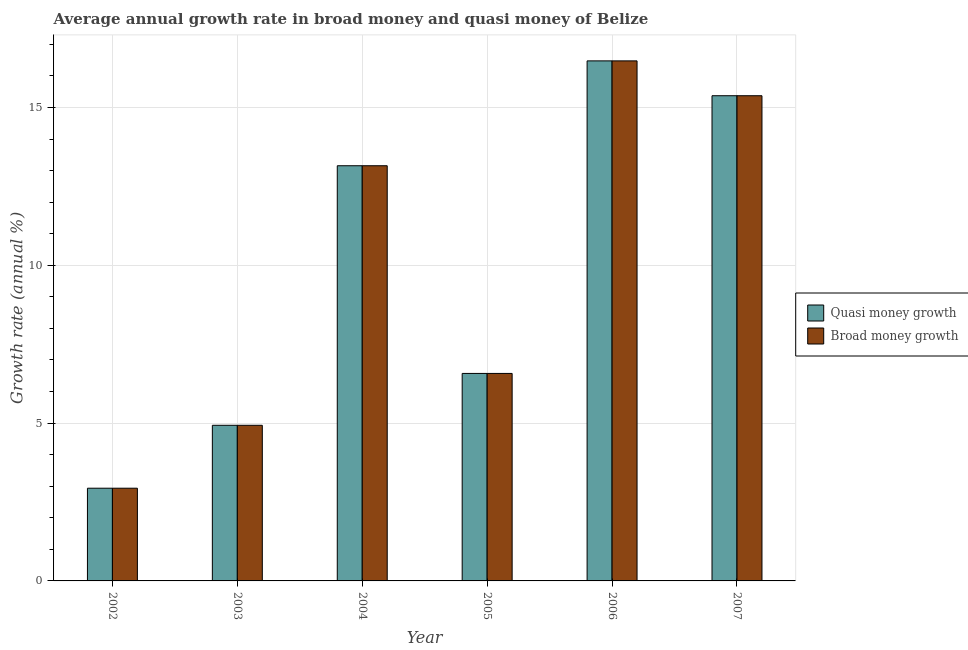How many different coloured bars are there?
Provide a short and direct response. 2. Are the number of bars per tick equal to the number of legend labels?
Ensure brevity in your answer.  Yes. How many bars are there on the 1st tick from the left?
Make the answer very short. 2. How many bars are there on the 1st tick from the right?
Your response must be concise. 2. What is the label of the 4th group of bars from the left?
Provide a short and direct response. 2005. What is the annual growth rate in quasi money in 2007?
Keep it short and to the point. 15.37. Across all years, what is the maximum annual growth rate in broad money?
Your response must be concise. 16.48. Across all years, what is the minimum annual growth rate in quasi money?
Your answer should be very brief. 2.94. In which year was the annual growth rate in quasi money minimum?
Ensure brevity in your answer.  2002. What is the total annual growth rate in quasi money in the graph?
Offer a very short reply. 59.44. What is the difference between the annual growth rate in quasi money in 2002 and that in 2004?
Your response must be concise. -10.22. What is the difference between the annual growth rate in broad money in 2005 and the annual growth rate in quasi money in 2007?
Ensure brevity in your answer.  -8.8. What is the average annual growth rate in quasi money per year?
Make the answer very short. 9.91. In the year 2005, what is the difference between the annual growth rate in quasi money and annual growth rate in broad money?
Offer a very short reply. 0. In how many years, is the annual growth rate in broad money greater than 14 %?
Your response must be concise. 2. What is the ratio of the annual growth rate in broad money in 2005 to that in 2007?
Make the answer very short. 0.43. What is the difference between the highest and the second highest annual growth rate in broad money?
Provide a short and direct response. 1.1. What is the difference between the highest and the lowest annual growth rate in quasi money?
Offer a very short reply. 13.54. In how many years, is the annual growth rate in quasi money greater than the average annual growth rate in quasi money taken over all years?
Keep it short and to the point. 3. What does the 1st bar from the left in 2004 represents?
Keep it short and to the point. Quasi money growth. What does the 2nd bar from the right in 2007 represents?
Make the answer very short. Quasi money growth. Are all the bars in the graph horizontal?
Your response must be concise. No. Are the values on the major ticks of Y-axis written in scientific E-notation?
Your answer should be very brief. No. Does the graph contain grids?
Keep it short and to the point. Yes. Where does the legend appear in the graph?
Provide a succinct answer. Center right. How many legend labels are there?
Offer a terse response. 2. How are the legend labels stacked?
Your answer should be compact. Vertical. What is the title of the graph?
Ensure brevity in your answer.  Average annual growth rate in broad money and quasi money of Belize. Does "Start a business" appear as one of the legend labels in the graph?
Your answer should be very brief. No. What is the label or title of the Y-axis?
Your answer should be compact. Growth rate (annual %). What is the Growth rate (annual %) of Quasi money growth in 2002?
Keep it short and to the point. 2.94. What is the Growth rate (annual %) in Broad money growth in 2002?
Make the answer very short. 2.94. What is the Growth rate (annual %) in Quasi money growth in 2003?
Provide a short and direct response. 4.93. What is the Growth rate (annual %) of Broad money growth in 2003?
Your answer should be compact. 4.93. What is the Growth rate (annual %) of Quasi money growth in 2004?
Your answer should be very brief. 13.15. What is the Growth rate (annual %) in Broad money growth in 2004?
Make the answer very short. 13.15. What is the Growth rate (annual %) of Quasi money growth in 2005?
Your answer should be very brief. 6.57. What is the Growth rate (annual %) of Broad money growth in 2005?
Provide a succinct answer. 6.57. What is the Growth rate (annual %) in Quasi money growth in 2006?
Your response must be concise. 16.48. What is the Growth rate (annual %) in Broad money growth in 2006?
Ensure brevity in your answer.  16.48. What is the Growth rate (annual %) of Quasi money growth in 2007?
Give a very brief answer. 15.37. What is the Growth rate (annual %) of Broad money growth in 2007?
Provide a succinct answer. 15.37. Across all years, what is the maximum Growth rate (annual %) of Quasi money growth?
Ensure brevity in your answer.  16.48. Across all years, what is the maximum Growth rate (annual %) of Broad money growth?
Give a very brief answer. 16.48. Across all years, what is the minimum Growth rate (annual %) in Quasi money growth?
Keep it short and to the point. 2.94. Across all years, what is the minimum Growth rate (annual %) of Broad money growth?
Keep it short and to the point. 2.94. What is the total Growth rate (annual %) of Quasi money growth in the graph?
Your response must be concise. 59.44. What is the total Growth rate (annual %) of Broad money growth in the graph?
Offer a very short reply. 59.44. What is the difference between the Growth rate (annual %) of Quasi money growth in 2002 and that in 2003?
Your answer should be very brief. -1.99. What is the difference between the Growth rate (annual %) in Broad money growth in 2002 and that in 2003?
Your answer should be very brief. -1.99. What is the difference between the Growth rate (annual %) of Quasi money growth in 2002 and that in 2004?
Keep it short and to the point. -10.22. What is the difference between the Growth rate (annual %) in Broad money growth in 2002 and that in 2004?
Your answer should be very brief. -10.22. What is the difference between the Growth rate (annual %) in Quasi money growth in 2002 and that in 2005?
Provide a succinct answer. -3.64. What is the difference between the Growth rate (annual %) of Broad money growth in 2002 and that in 2005?
Your answer should be very brief. -3.64. What is the difference between the Growth rate (annual %) in Quasi money growth in 2002 and that in 2006?
Provide a succinct answer. -13.54. What is the difference between the Growth rate (annual %) in Broad money growth in 2002 and that in 2006?
Your response must be concise. -13.54. What is the difference between the Growth rate (annual %) of Quasi money growth in 2002 and that in 2007?
Provide a succinct answer. -12.43. What is the difference between the Growth rate (annual %) in Broad money growth in 2002 and that in 2007?
Offer a terse response. -12.43. What is the difference between the Growth rate (annual %) of Quasi money growth in 2003 and that in 2004?
Your response must be concise. -8.22. What is the difference between the Growth rate (annual %) in Broad money growth in 2003 and that in 2004?
Ensure brevity in your answer.  -8.22. What is the difference between the Growth rate (annual %) of Quasi money growth in 2003 and that in 2005?
Ensure brevity in your answer.  -1.64. What is the difference between the Growth rate (annual %) in Broad money growth in 2003 and that in 2005?
Provide a succinct answer. -1.64. What is the difference between the Growth rate (annual %) of Quasi money growth in 2003 and that in 2006?
Provide a short and direct response. -11.54. What is the difference between the Growth rate (annual %) of Broad money growth in 2003 and that in 2006?
Your answer should be compact. -11.54. What is the difference between the Growth rate (annual %) in Quasi money growth in 2003 and that in 2007?
Offer a very short reply. -10.44. What is the difference between the Growth rate (annual %) in Broad money growth in 2003 and that in 2007?
Give a very brief answer. -10.44. What is the difference between the Growth rate (annual %) in Quasi money growth in 2004 and that in 2005?
Keep it short and to the point. 6.58. What is the difference between the Growth rate (annual %) in Broad money growth in 2004 and that in 2005?
Offer a terse response. 6.58. What is the difference between the Growth rate (annual %) of Quasi money growth in 2004 and that in 2006?
Offer a terse response. -3.32. What is the difference between the Growth rate (annual %) in Broad money growth in 2004 and that in 2006?
Give a very brief answer. -3.32. What is the difference between the Growth rate (annual %) in Quasi money growth in 2004 and that in 2007?
Offer a very short reply. -2.22. What is the difference between the Growth rate (annual %) in Broad money growth in 2004 and that in 2007?
Your response must be concise. -2.22. What is the difference between the Growth rate (annual %) in Quasi money growth in 2005 and that in 2006?
Offer a very short reply. -9.9. What is the difference between the Growth rate (annual %) of Broad money growth in 2005 and that in 2006?
Make the answer very short. -9.9. What is the difference between the Growth rate (annual %) of Quasi money growth in 2005 and that in 2007?
Keep it short and to the point. -8.8. What is the difference between the Growth rate (annual %) of Broad money growth in 2005 and that in 2007?
Give a very brief answer. -8.8. What is the difference between the Growth rate (annual %) in Quasi money growth in 2006 and that in 2007?
Provide a succinct answer. 1.1. What is the difference between the Growth rate (annual %) of Broad money growth in 2006 and that in 2007?
Your answer should be compact. 1.1. What is the difference between the Growth rate (annual %) in Quasi money growth in 2002 and the Growth rate (annual %) in Broad money growth in 2003?
Give a very brief answer. -1.99. What is the difference between the Growth rate (annual %) of Quasi money growth in 2002 and the Growth rate (annual %) of Broad money growth in 2004?
Offer a very short reply. -10.22. What is the difference between the Growth rate (annual %) of Quasi money growth in 2002 and the Growth rate (annual %) of Broad money growth in 2005?
Your response must be concise. -3.64. What is the difference between the Growth rate (annual %) in Quasi money growth in 2002 and the Growth rate (annual %) in Broad money growth in 2006?
Your response must be concise. -13.54. What is the difference between the Growth rate (annual %) of Quasi money growth in 2002 and the Growth rate (annual %) of Broad money growth in 2007?
Offer a very short reply. -12.43. What is the difference between the Growth rate (annual %) of Quasi money growth in 2003 and the Growth rate (annual %) of Broad money growth in 2004?
Provide a short and direct response. -8.22. What is the difference between the Growth rate (annual %) of Quasi money growth in 2003 and the Growth rate (annual %) of Broad money growth in 2005?
Your answer should be very brief. -1.64. What is the difference between the Growth rate (annual %) of Quasi money growth in 2003 and the Growth rate (annual %) of Broad money growth in 2006?
Your answer should be compact. -11.54. What is the difference between the Growth rate (annual %) of Quasi money growth in 2003 and the Growth rate (annual %) of Broad money growth in 2007?
Your response must be concise. -10.44. What is the difference between the Growth rate (annual %) in Quasi money growth in 2004 and the Growth rate (annual %) in Broad money growth in 2005?
Offer a very short reply. 6.58. What is the difference between the Growth rate (annual %) in Quasi money growth in 2004 and the Growth rate (annual %) in Broad money growth in 2006?
Make the answer very short. -3.32. What is the difference between the Growth rate (annual %) of Quasi money growth in 2004 and the Growth rate (annual %) of Broad money growth in 2007?
Keep it short and to the point. -2.22. What is the difference between the Growth rate (annual %) in Quasi money growth in 2005 and the Growth rate (annual %) in Broad money growth in 2006?
Keep it short and to the point. -9.9. What is the difference between the Growth rate (annual %) of Quasi money growth in 2005 and the Growth rate (annual %) of Broad money growth in 2007?
Provide a succinct answer. -8.8. What is the difference between the Growth rate (annual %) in Quasi money growth in 2006 and the Growth rate (annual %) in Broad money growth in 2007?
Make the answer very short. 1.1. What is the average Growth rate (annual %) in Quasi money growth per year?
Ensure brevity in your answer.  9.91. What is the average Growth rate (annual %) in Broad money growth per year?
Keep it short and to the point. 9.91. In the year 2002, what is the difference between the Growth rate (annual %) in Quasi money growth and Growth rate (annual %) in Broad money growth?
Offer a terse response. 0. In the year 2004, what is the difference between the Growth rate (annual %) of Quasi money growth and Growth rate (annual %) of Broad money growth?
Offer a very short reply. 0. In the year 2005, what is the difference between the Growth rate (annual %) of Quasi money growth and Growth rate (annual %) of Broad money growth?
Provide a succinct answer. 0. In the year 2006, what is the difference between the Growth rate (annual %) of Quasi money growth and Growth rate (annual %) of Broad money growth?
Give a very brief answer. 0. What is the ratio of the Growth rate (annual %) of Quasi money growth in 2002 to that in 2003?
Ensure brevity in your answer.  0.6. What is the ratio of the Growth rate (annual %) of Broad money growth in 2002 to that in 2003?
Give a very brief answer. 0.6. What is the ratio of the Growth rate (annual %) of Quasi money growth in 2002 to that in 2004?
Your response must be concise. 0.22. What is the ratio of the Growth rate (annual %) of Broad money growth in 2002 to that in 2004?
Offer a very short reply. 0.22. What is the ratio of the Growth rate (annual %) of Quasi money growth in 2002 to that in 2005?
Your response must be concise. 0.45. What is the ratio of the Growth rate (annual %) in Broad money growth in 2002 to that in 2005?
Offer a very short reply. 0.45. What is the ratio of the Growth rate (annual %) of Quasi money growth in 2002 to that in 2006?
Give a very brief answer. 0.18. What is the ratio of the Growth rate (annual %) of Broad money growth in 2002 to that in 2006?
Give a very brief answer. 0.18. What is the ratio of the Growth rate (annual %) of Quasi money growth in 2002 to that in 2007?
Offer a very short reply. 0.19. What is the ratio of the Growth rate (annual %) in Broad money growth in 2002 to that in 2007?
Offer a terse response. 0.19. What is the ratio of the Growth rate (annual %) of Quasi money growth in 2003 to that in 2004?
Your answer should be compact. 0.37. What is the ratio of the Growth rate (annual %) of Broad money growth in 2003 to that in 2004?
Offer a terse response. 0.37. What is the ratio of the Growth rate (annual %) of Quasi money growth in 2003 to that in 2005?
Provide a succinct answer. 0.75. What is the ratio of the Growth rate (annual %) in Broad money growth in 2003 to that in 2005?
Offer a very short reply. 0.75. What is the ratio of the Growth rate (annual %) in Quasi money growth in 2003 to that in 2006?
Make the answer very short. 0.3. What is the ratio of the Growth rate (annual %) in Broad money growth in 2003 to that in 2006?
Provide a short and direct response. 0.3. What is the ratio of the Growth rate (annual %) of Quasi money growth in 2003 to that in 2007?
Offer a terse response. 0.32. What is the ratio of the Growth rate (annual %) of Broad money growth in 2003 to that in 2007?
Provide a short and direct response. 0.32. What is the ratio of the Growth rate (annual %) in Quasi money growth in 2004 to that in 2005?
Keep it short and to the point. 2. What is the ratio of the Growth rate (annual %) in Broad money growth in 2004 to that in 2005?
Your answer should be compact. 2. What is the ratio of the Growth rate (annual %) in Quasi money growth in 2004 to that in 2006?
Keep it short and to the point. 0.8. What is the ratio of the Growth rate (annual %) of Broad money growth in 2004 to that in 2006?
Ensure brevity in your answer.  0.8. What is the ratio of the Growth rate (annual %) of Quasi money growth in 2004 to that in 2007?
Provide a short and direct response. 0.86. What is the ratio of the Growth rate (annual %) in Broad money growth in 2004 to that in 2007?
Your answer should be very brief. 0.86. What is the ratio of the Growth rate (annual %) in Quasi money growth in 2005 to that in 2006?
Provide a short and direct response. 0.4. What is the ratio of the Growth rate (annual %) of Broad money growth in 2005 to that in 2006?
Offer a terse response. 0.4. What is the ratio of the Growth rate (annual %) of Quasi money growth in 2005 to that in 2007?
Make the answer very short. 0.43. What is the ratio of the Growth rate (annual %) in Broad money growth in 2005 to that in 2007?
Offer a terse response. 0.43. What is the ratio of the Growth rate (annual %) in Quasi money growth in 2006 to that in 2007?
Give a very brief answer. 1.07. What is the ratio of the Growth rate (annual %) of Broad money growth in 2006 to that in 2007?
Offer a very short reply. 1.07. What is the difference between the highest and the second highest Growth rate (annual %) of Quasi money growth?
Keep it short and to the point. 1.1. What is the difference between the highest and the second highest Growth rate (annual %) of Broad money growth?
Offer a very short reply. 1.1. What is the difference between the highest and the lowest Growth rate (annual %) of Quasi money growth?
Provide a succinct answer. 13.54. What is the difference between the highest and the lowest Growth rate (annual %) of Broad money growth?
Your answer should be very brief. 13.54. 